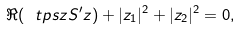Convert formula to latex. <formula><loc_0><loc_0><loc_500><loc_500>\Re ( \ t p s { z } S ^ { \prime } z ) + | z _ { 1 } | ^ { 2 } + | z _ { 2 } | ^ { 2 } = 0 ,</formula> 